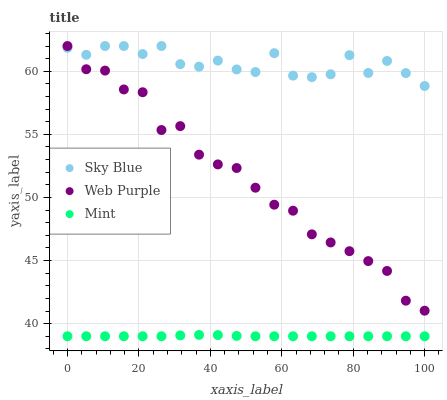Does Mint have the minimum area under the curve?
Answer yes or no. Yes. Does Sky Blue have the maximum area under the curve?
Answer yes or no. Yes. Does Web Purple have the minimum area under the curve?
Answer yes or no. No. Does Web Purple have the maximum area under the curve?
Answer yes or no. No. Is Mint the smoothest?
Answer yes or no. Yes. Is Sky Blue the roughest?
Answer yes or no. Yes. Is Web Purple the smoothest?
Answer yes or no. No. Is Web Purple the roughest?
Answer yes or no. No. Does Mint have the lowest value?
Answer yes or no. Yes. Does Web Purple have the lowest value?
Answer yes or no. No. Does Web Purple have the highest value?
Answer yes or no. Yes. Does Mint have the highest value?
Answer yes or no. No. Is Mint less than Sky Blue?
Answer yes or no. Yes. Is Sky Blue greater than Mint?
Answer yes or no. Yes. Does Web Purple intersect Sky Blue?
Answer yes or no. Yes. Is Web Purple less than Sky Blue?
Answer yes or no. No. Is Web Purple greater than Sky Blue?
Answer yes or no. No. Does Mint intersect Sky Blue?
Answer yes or no. No. 